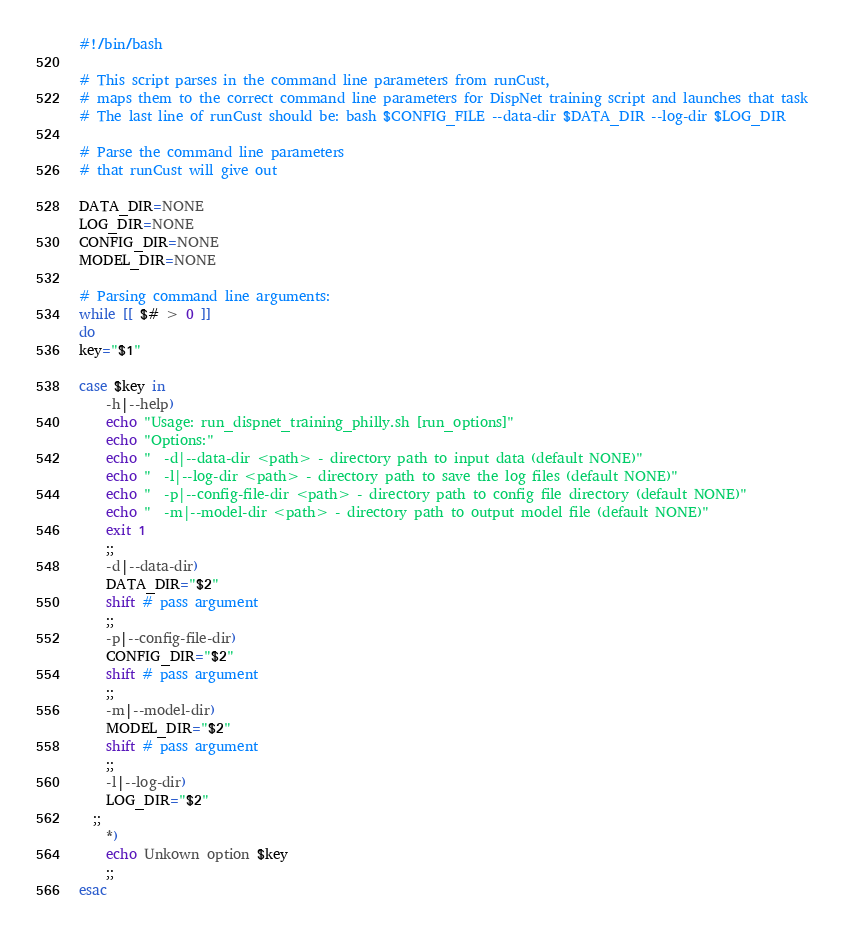Convert code to text. <code><loc_0><loc_0><loc_500><loc_500><_Bash_>#!/bin/bash

# This script parses in the command line parameters from runCust, 
# maps them to the correct command line parameters for DispNet training script and launches that task
# The last line of runCust should be: bash $CONFIG_FILE --data-dir $DATA_DIR --log-dir $LOG_DIR

# Parse the command line parameters
# that runCust will give out

DATA_DIR=NONE
LOG_DIR=NONE
CONFIG_DIR=NONE
MODEL_DIR=NONE

# Parsing command line arguments:
while [[ $# > 0 ]]
do
key="$1"

case $key in
    -h|--help)
    echo "Usage: run_dispnet_training_philly.sh [run_options]"
    echo "Options:"
    echo "  -d|--data-dir <path> - directory path to input data (default NONE)"
    echo "  -l|--log-dir <path> - directory path to save the log files (default NONE)"
    echo "  -p|--config-file-dir <path> - directory path to config file directory (default NONE)"
    echo "  -m|--model-dir <path> - directory path to output model file (default NONE)"
    exit 1
    ;;
    -d|--data-dir)
    DATA_DIR="$2"
    shift # pass argument
    ;;
    -p|--config-file-dir)
    CONFIG_DIR="$2"
    shift # pass argument
    ;;
    -m|--model-dir)
    MODEL_DIR="$2"
    shift # pass argument
    ;;
    -l|--log-dir)
    LOG_DIR="$2"
  ;;
    *)
    echo Unkown option $key
    ;;
esac</code> 